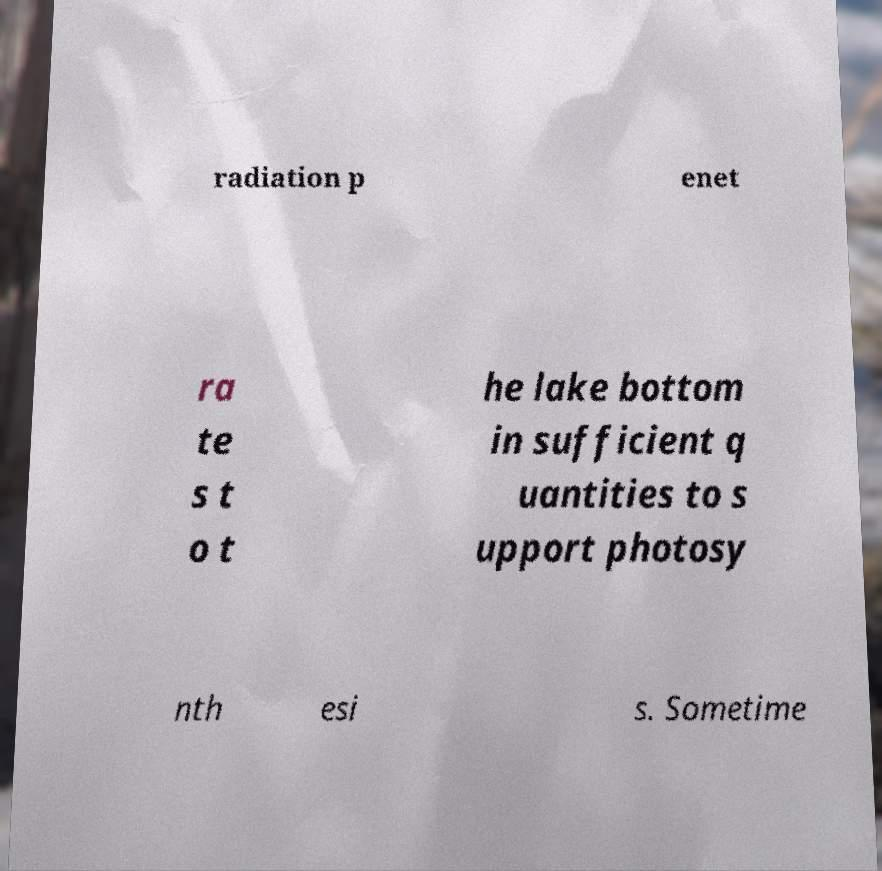Could you assist in decoding the text presented in this image and type it out clearly? radiation p enet ra te s t o t he lake bottom in sufficient q uantities to s upport photosy nth esi s. Sometime 